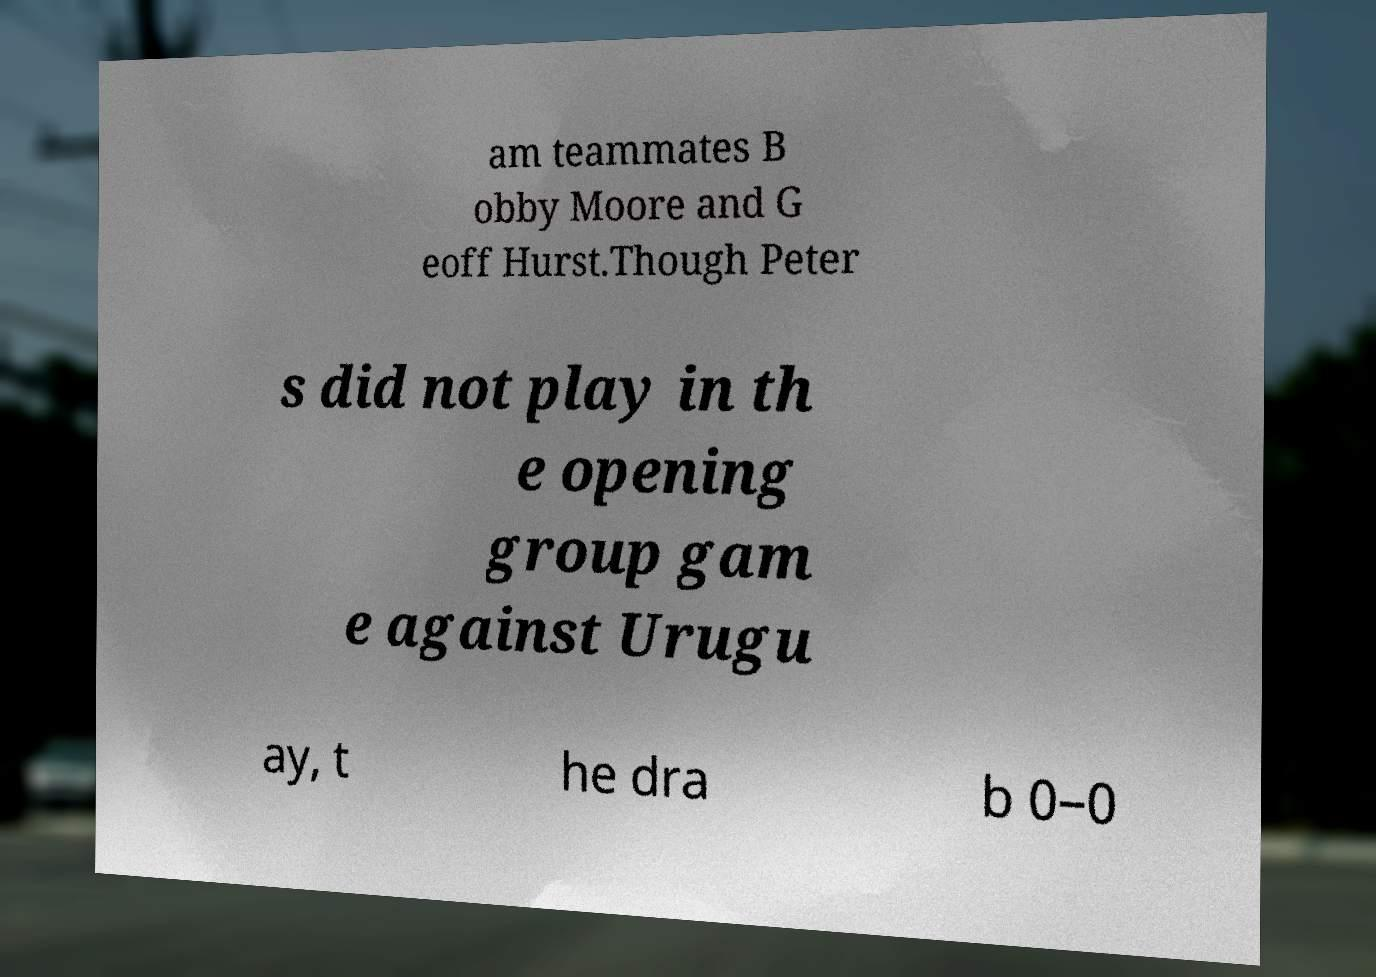Can you read and provide the text displayed in the image?This photo seems to have some interesting text. Can you extract and type it out for me? am teammates B obby Moore and G eoff Hurst.Though Peter s did not play in th e opening group gam e against Urugu ay, t he dra b 0–0 